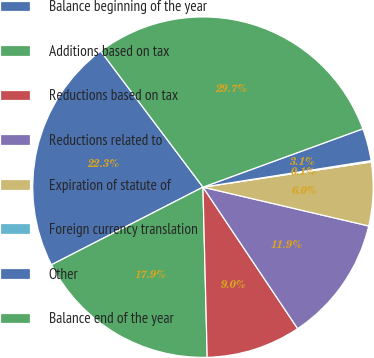Convert chart. <chart><loc_0><loc_0><loc_500><loc_500><pie_chart><fcel>Balance beginning of the year<fcel>Additions based on tax<fcel>Reductions based on tax<fcel>Reductions related to<fcel>Expiration of statute of<fcel>Foreign currency translation<fcel>Other<fcel>Balance end of the year<nl><fcel>22.28%<fcel>17.86%<fcel>8.99%<fcel>11.95%<fcel>6.03%<fcel>0.12%<fcel>3.08%<fcel>29.69%<nl></chart> 